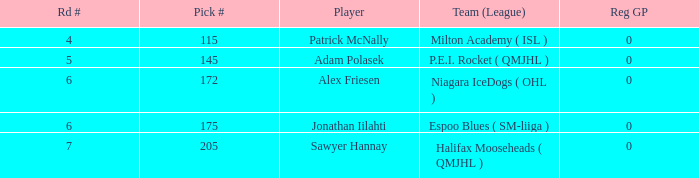What's sawyer hannay's overall selection number? 1.0. 